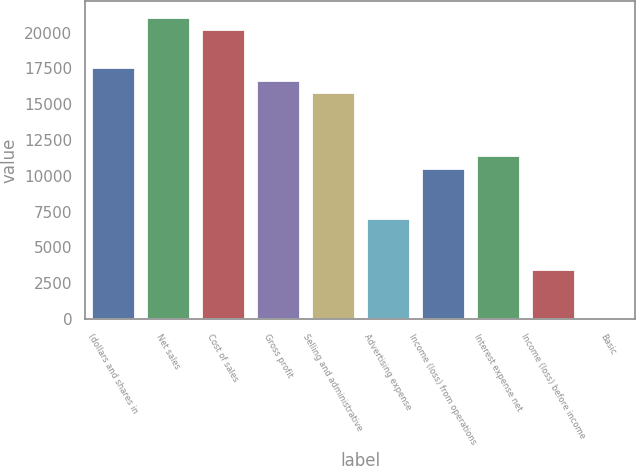Convert chart to OTSL. <chart><loc_0><loc_0><loc_500><loc_500><bar_chart><fcel>(dollars and shares in<fcel>Net sales<fcel>Cost of sales<fcel>Gross profit<fcel>Selling and administrative<fcel>Advertising expense<fcel>Income (loss) from operations<fcel>Interest expense net<fcel>Income (loss) before income<fcel>Basic<nl><fcel>17602.2<fcel>21122.6<fcel>20242.5<fcel>16722.1<fcel>15842<fcel>7041<fcel>10561.4<fcel>11441.5<fcel>3520.6<fcel>0.2<nl></chart> 